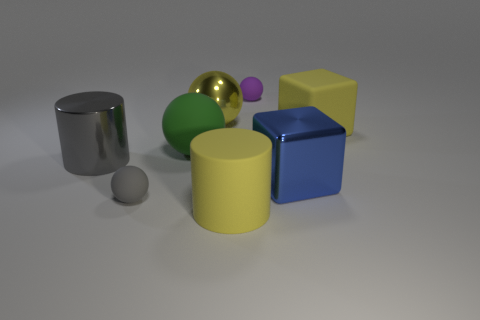The tiny matte thing that is the same color as the large metal cylinder is what shape?
Make the answer very short. Sphere. How many other things are the same shape as the gray rubber object?
Offer a terse response. 3. What number of big objects are there?
Offer a terse response. 6. What number of blocks have the same size as the purple rubber sphere?
Give a very brief answer. 0. What is the gray ball made of?
Ensure brevity in your answer.  Rubber. Is the color of the rubber cylinder the same as the big metal object behind the big gray cylinder?
Your response must be concise. Yes. There is a matte ball that is both to the left of the big yellow matte cylinder and behind the big blue object; what size is it?
Your response must be concise. Large. What is the shape of the green object that is made of the same material as the yellow block?
Your answer should be very brief. Sphere. Is the material of the big yellow cylinder the same as the big block left of the big yellow cube?
Give a very brief answer. No. There is a large cylinder that is on the right side of the gray shiny cylinder; is there a gray cylinder that is behind it?
Your response must be concise. Yes. 